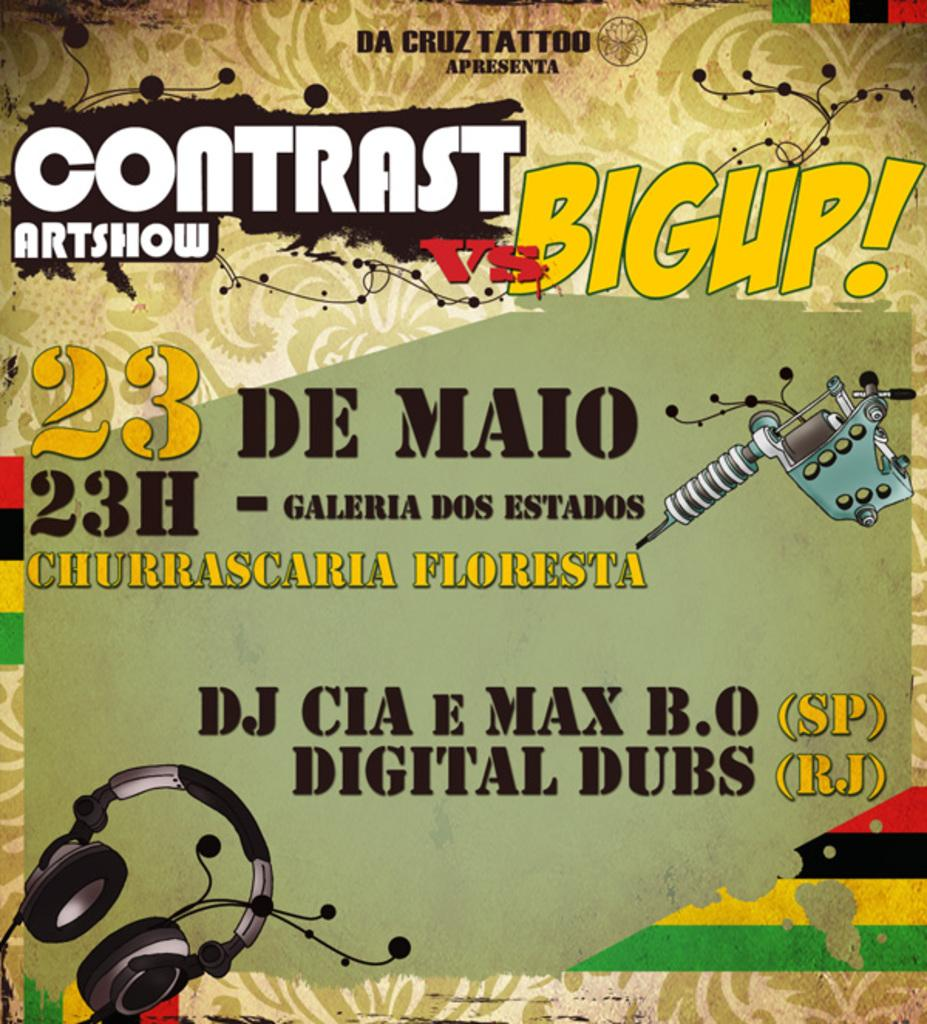<image>
Render a clear and concise summary of the photo. an ad about a band and when they are playing 